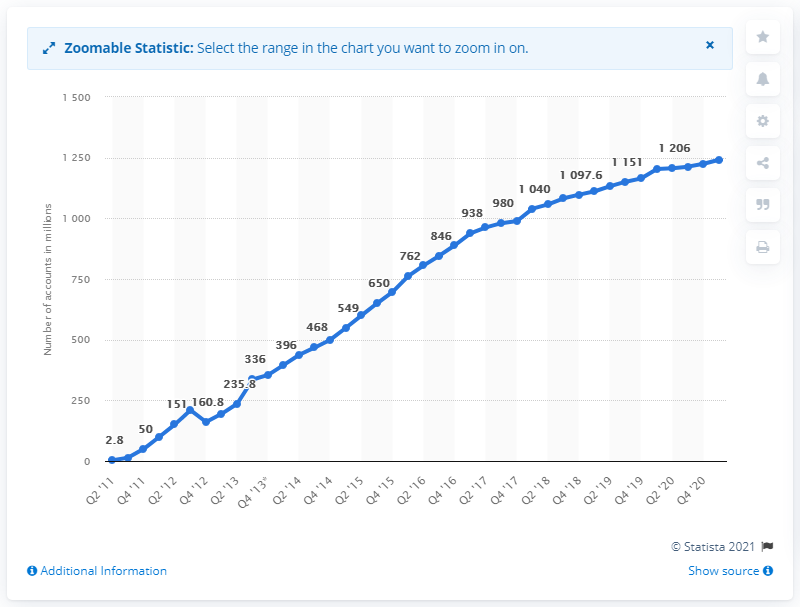Draw attention to some important aspects in this diagram. The difference between the highest value and the lowest value in millions is 1203.2. In the first quarter of 2021, WeChat had approximately 1,241.6 million monthly active users. The title of the y-axis is "Number of accounts in millions. 